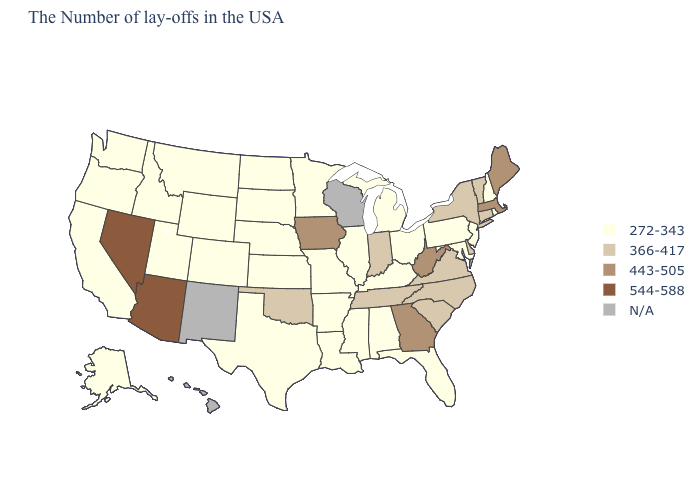What is the value of South Carolina?
Be succinct. 366-417. Name the states that have a value in the range 544-588?
Concise answer only. Arizona, Nevada. What is the lowest value in the USA?
Quick response, please. 272-343. Among the states that border Ohio , does Kentucky have the highest value?
Give a very brief answer. No. Does Delaware have the highest value in the South?
Quick response, please. No. Does the map have missing data?
Be succinct. Yes. What is the lowest value in states that border Texas?
Keep it brief. 272-343. Does the map have missing data?
Concise answer only. Yes. Name the states that have a value in the range N/A?
Quick response, please. Wisconsin, New Mexico, Hawaii. Among the states that border New Mexico , does Arizona have the lowest value?
Keep it brief. No. Name the states that have a value in the range 544-588?
Quick response, please. Arizona, Nevada. What is the lowest value in states that border Rhode Island?
Quick response, please. 366-417. Name the states that have a value in the range 366-417?
Keep it brief. Vermont, Connecticut, New York, Delaware, Virginia, North Carolina, South Carolina, Indiana, Tennessee, Oklahoma. 